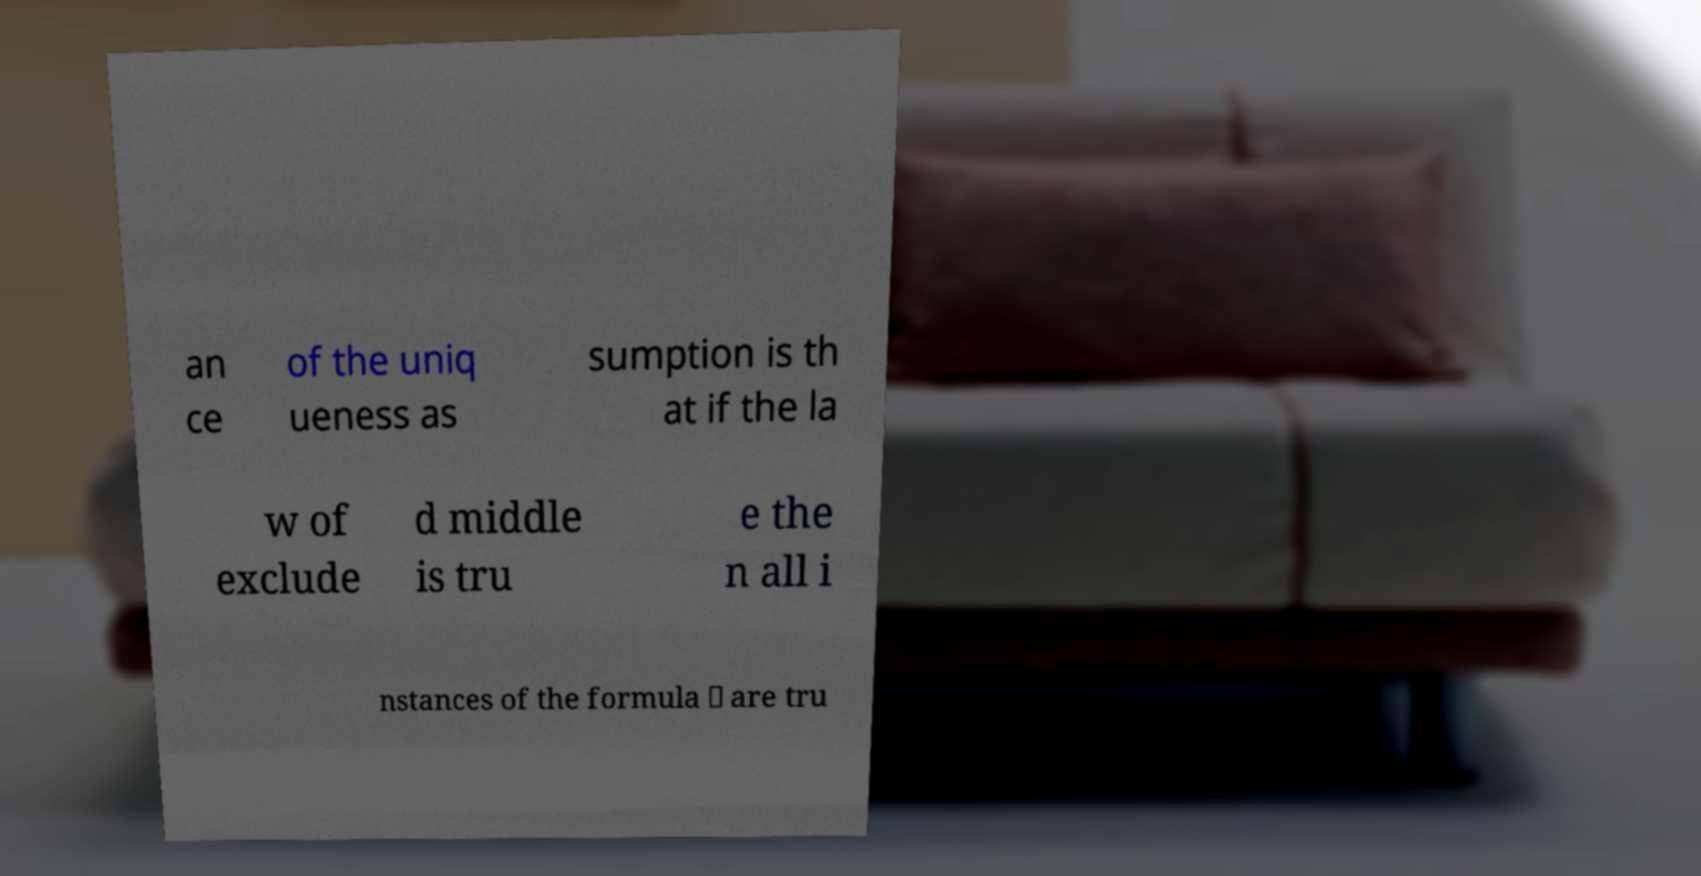What messages or text are displayed in this image? I need them in a readable, typed format. an ce of the uniq ueness as sumption is th at if the la w of exclude d middle is tru e the n all i nstances of the formula ∨ are tru 